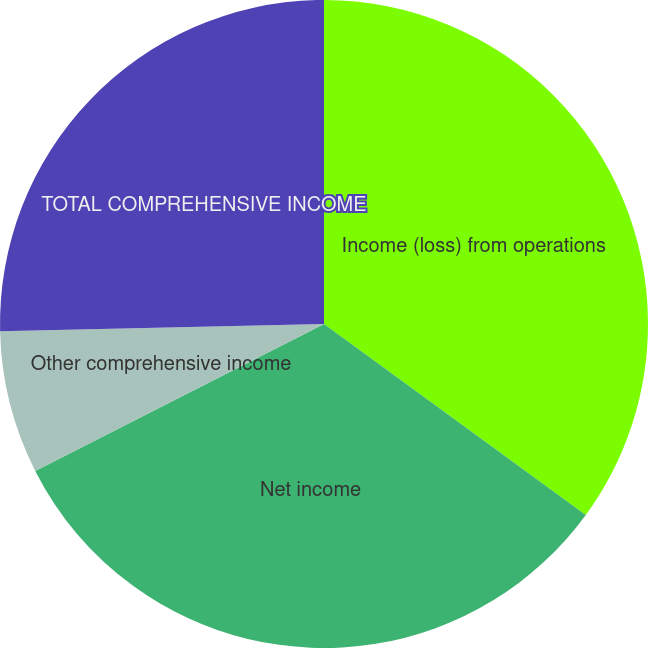Convert chart. <chart><loc_0><loc_0><loc_500><loc_500><pie_chart><fcel>Income (loss) from operations<fcel>Net income<fcel>Other comprehensive income<fcel>TOTAL COMPREHENSIVE INCOME<nl><fcel>35.03%<fcel>32.48%<fcel>7.13%<fcel>25.36%<nl></chart> 